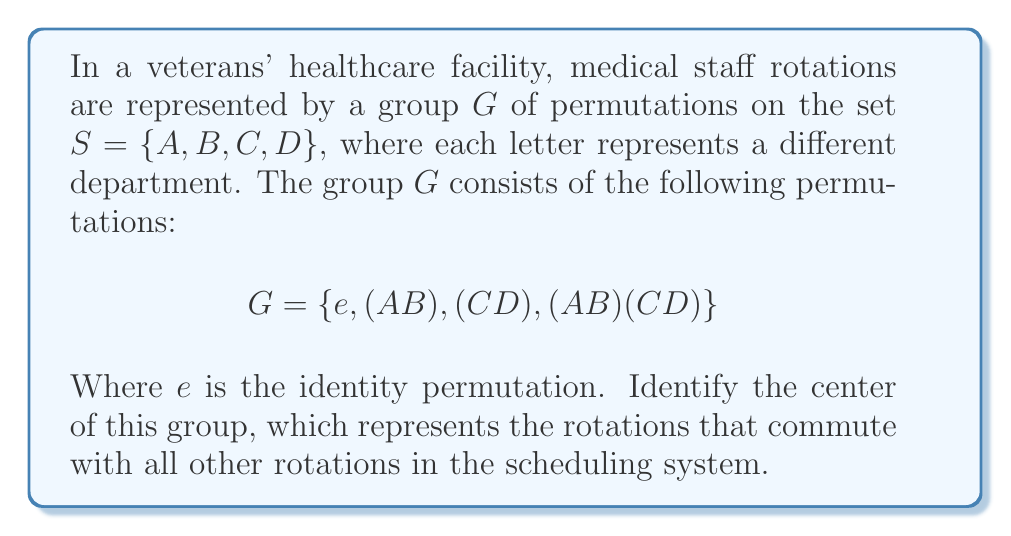Can you solve this math problem? To find the center of the group $G$, we need to identify all elements that commute with every other element in the group. Let's follow these steps:

1) First, recall that the center of a group $G$ is defined as:
   $$Z(G) = \{z \in G : zg = gz \text{ for all } g \in G\}$$

2) We need to check each element of $G$ against all other elements:

   a) The identity element $e$ always commutes with every element, so $e$ is in $Z(G)$.

   b) Let's check $(AB)$:
      - $(AB) \cdot e = e \cdot (AB)$
      - $(AB) \cdot (AB) = (AB) \cdot (AB)$
      - $(AB) \cdot (CD) = (CD) \cdot (AB)$
      - $(AB) \cdot (AB)(CD) = (CD) = (AB)(CD) \cdot (AB)$
      So, $(AB)$ commutes with all elements and is in $Z(G)$.

   c) Let's check $(CD)$:
      - $(CD) \cdot e = e \cdot (CD)$
      - $(CD) \cdot (AB) = (AB) \cdot (CD)$
      - $(CD) \cdot (CD) = (CD) \cdot (CD)$
      - $(CD) \cdot (AB)(CD) = (AB) = (AB)(CD) \cdot (CD)$
      So, $(CD)$ commutes with all elements and is in $Z(G)$.

   d) Finally, let's check $(AB)(CD)$:
      - $(AB)(CD) \cdot e = e \cdot (AB)(CD)$
      - $(AB)(CD) \cdot (AB) = (CD) = (AB) \cdot (AB)(CD)$
      - $(AB)(CD) \cdot (CD) = (AB) = (CD) \cdot (AB)(CD)$
      - $(AB)(CD) \cdot (AB)(CD) = (AB)(CD) \cdot (AB)(CD)$
      So, $(AB)(CD)$ commutes with all elements and is in $Z(G)$.

3) Therefore, all elements of $G$ commute with each other, meaning the center of $G$ is $G$ itself.
Answer: $Z(G) = G = \{e, (AB), (CD), (AB)(CD)\}$ 